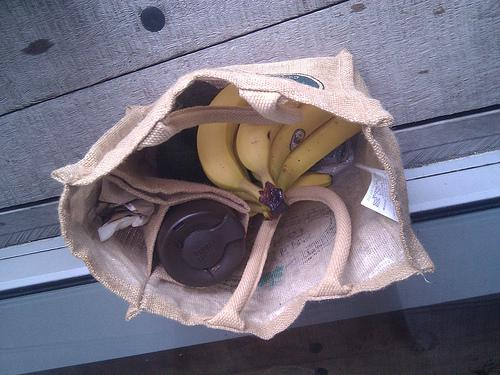Question: what material is the bag made of?
Choices:
A. Hemp.
B. Plastic.
C. Burlap.
D. Leather.
Answer with the letter. Answer: C Question: what is the bag sitting on?
Choices:
A. The kitchen counter.
B. Wood.
C. The woman's lap.
D. A conveyor belt.
Answer with the letter. Answer: B Question: what color are the bananas?
Choices:
A. Yellow.
B. Green.
C. Black.
D. Brown.
Answer with the letter. Answer: A Question: what are the yellow fruits?
Choices:
A. Lemons.
B. Bananas.
C. Grapefruits.
D. Pineapple.
Answer with the letter. Answer: B 